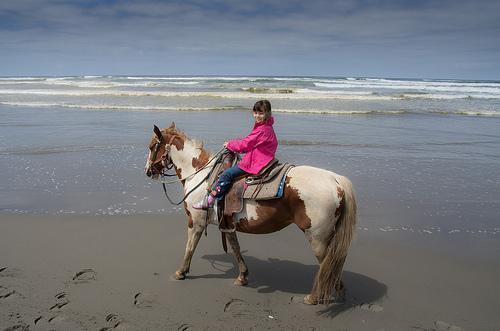How many horses are there?
Give a very brief answer. 1. 